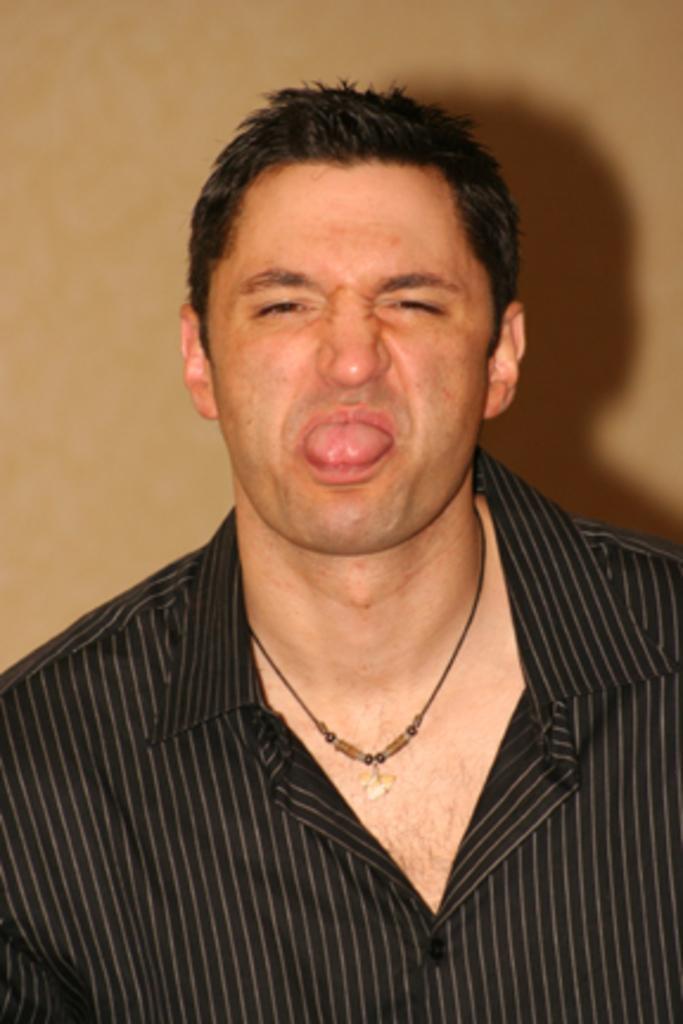Please provide a concise description of this image. In this image we can see a person wearing a shirt and in the background, we can see the wall. 